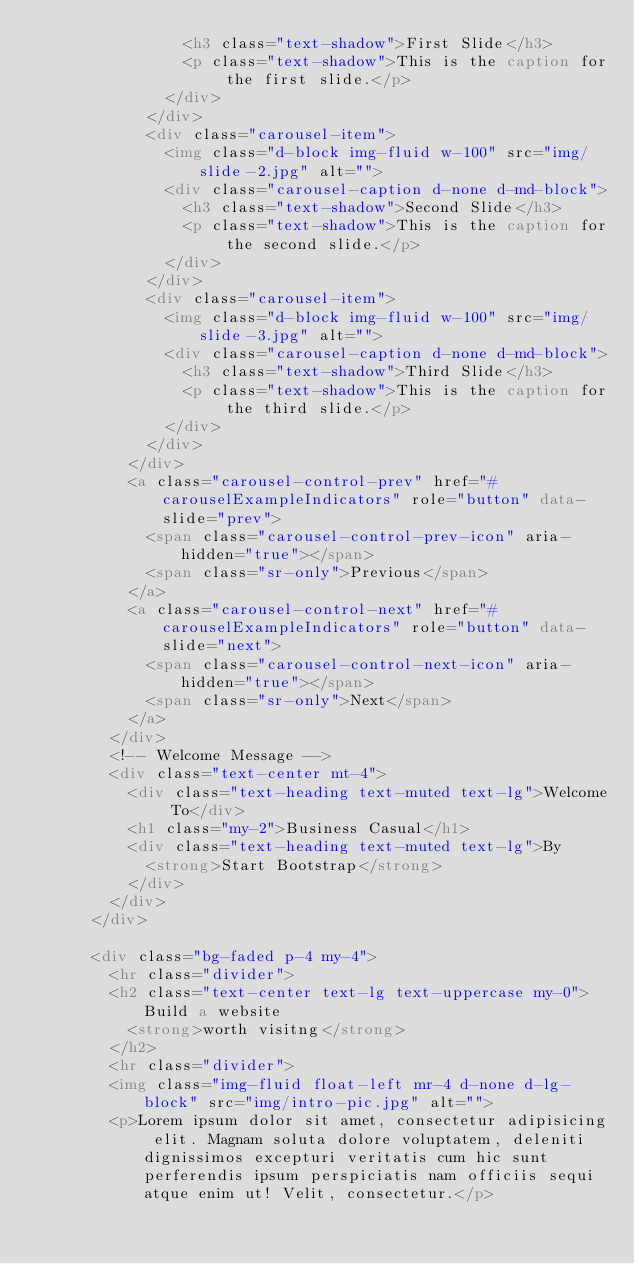Convert code to text. <code><loc_0><loc_0><loc_500><loc_500><_HTML_>                <h3 class="text-shadow">First Slide</h3>
                <p class="text-shadow">This is the caption for the first slide.</p>
              </div>
            </div>
            <div class="carousel-item">
              <img class="d-block img-fluid w-100" src="img/slide-2.jpg" alt="">
              <div class="carousel-caption d-none d-md-block">
                <h3 class="text-shadow">Second Slide</h3>
                <p class="text-shadow">This is the caption for the second slide.</p>
              </div>
            </div>
            <div class="carousel-item">
              <img class="d-block img-fluid w-100" src="img/slide-3.jpg" alt="">
              <div class="carousel-caption d-none d-md-block">
                <h3 class="text-shadow">Third Slide</h3>
                <p class="text-shadow">This is the caption for the third slide.</p>
              </div>
            </div>
          </div>
          <a class="carousel-control-prev" href="#carouselExampleIndicators" role="button" data-slide="prev">
            <span class="carousel-control-prev-icon" aria-hidden="true"></span>
            <span class="sr-only">Previous</span>
          </a>
          <a class="carousel-control-next" href="#carouselExampleIndicators" role="button" data-slide="next">
            <span class="carousel-control-next-icon" aria-hidden="true"></span>
            <span class="sr-only">Next</span>
          </a>
        </div>
        <!-- Welcome Message -->
        <div class="text-center mt-4">
          <div class="text-heading text-muted text-lg">Welcome To</div>
          <h1 class="my-2">Business Casual</h1>
          <div class="text-heading text-muted text-lg">By
            <strong>Start Bootstrap</strong>
          </div>
        </div>
      </div>

      <div class="bg-faded p-4 my-4">
        <hr class="divider">
        <h2 class="text-center text-lg text-uppercase my-0">Build a website
          <strong>worth visitng</strong>
        </h2>
        <hr class="divider">
        <img class="img-fluid float-left mr-4 d-none d-lg-block" src="img/intro-pic.jpg" alt="">
        <p>Lorem ipsum dolor sit amet, consectetur adipisicing elit. Magnam soluta dolore voluptatem, deleniti dignissimos excepturi veritatis cum hic sunt perferendis ipsum perspiciatis nam officiis sequi atque enim ut! Velit, consectetur.</p></code> 